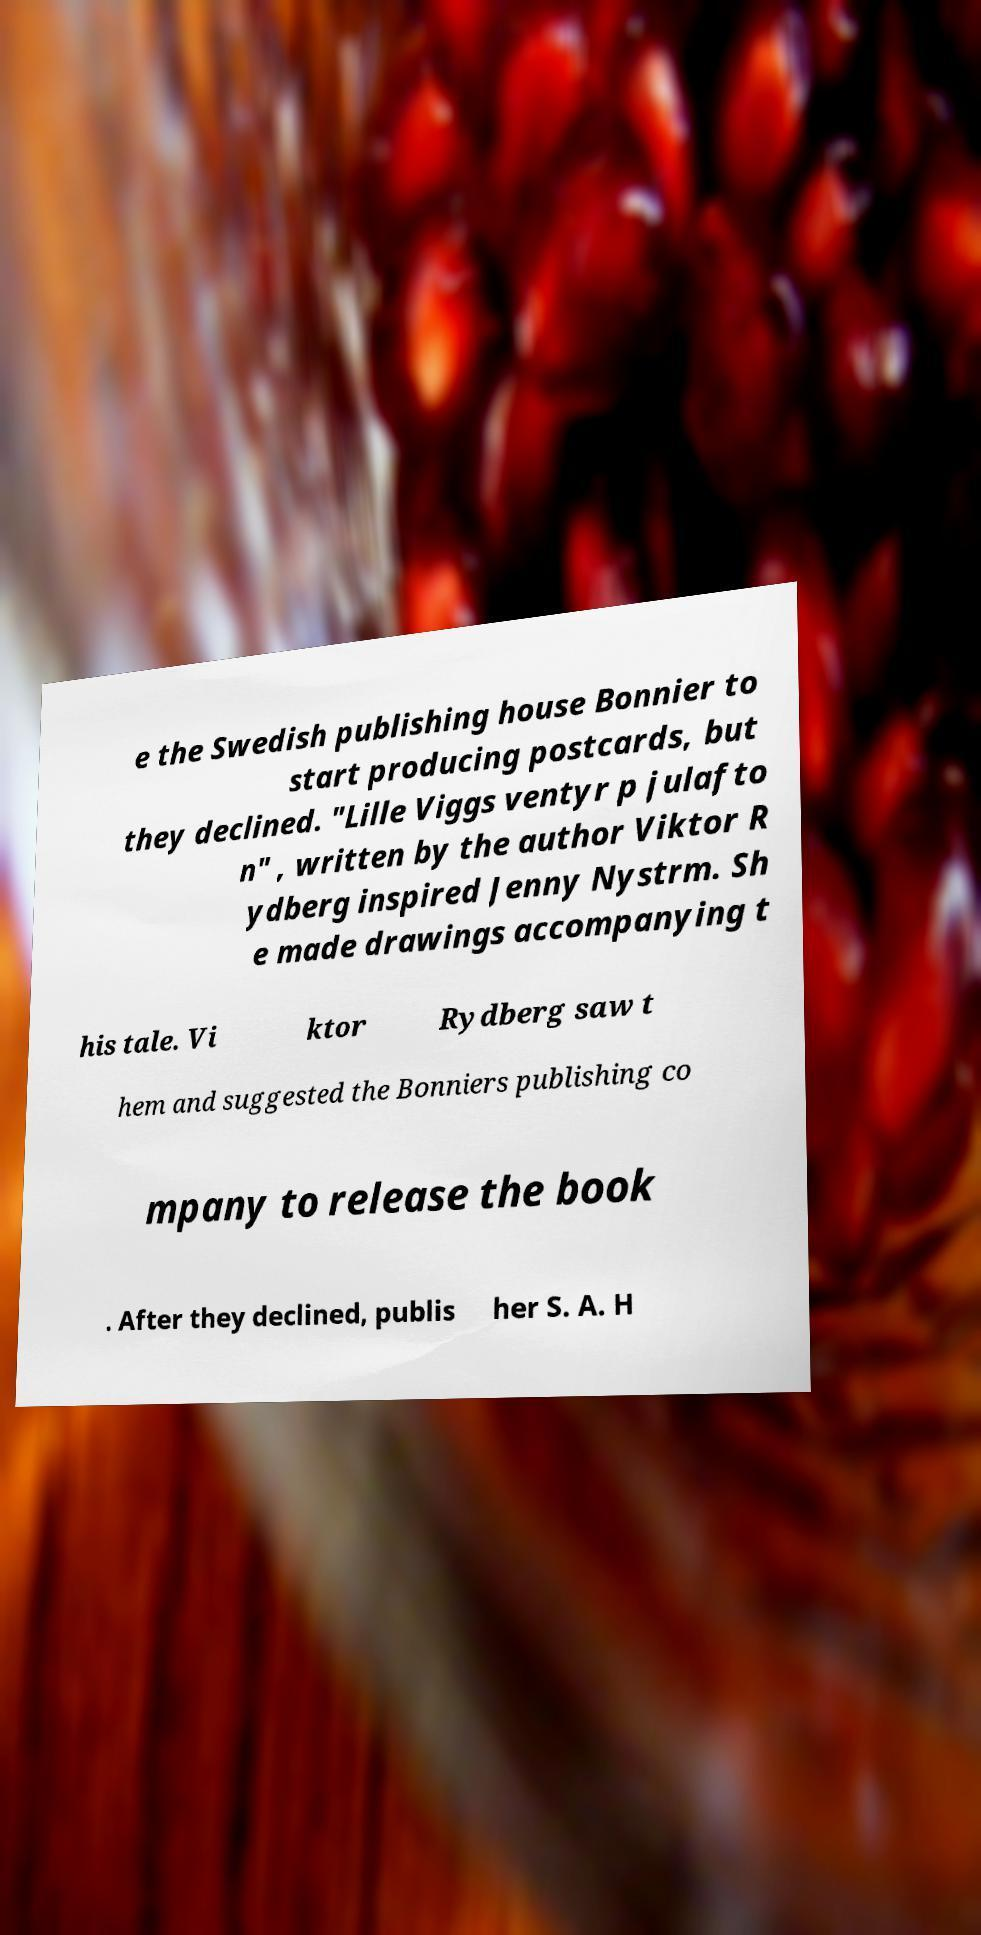Can you read and provide the text displayed in the image?This photo seems to have some interesting text. Can you extract and type it out for me? e the Swedish publishing house Bonnier to start producing postcards, but they declined. "Lille Viggs ventyr p julafto n" , written by the author Viktor R ydberg inspired Jenny Nystrm. Sh e made drawings accompanying t his tale. Vi ktor Rydberg saw t hem and suggested the Bonniers publishing co mpany to release the book . After they declined, publis her S. A. H 